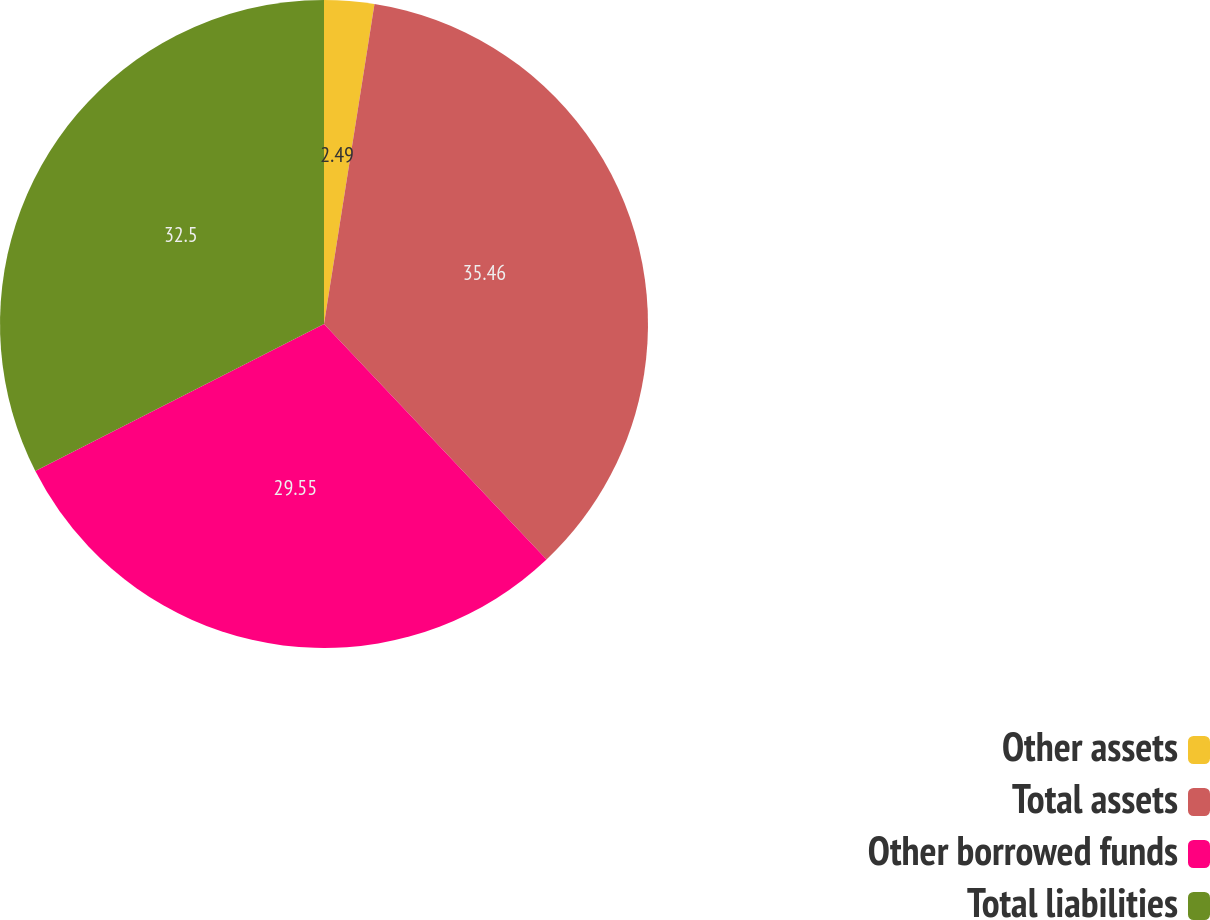<chart> <loc_0><loc_0><loc_500><loc_500><pie_chart><fcel>Other assets<fcel>Total assets<fcel>Other borrowed funds<fcel>Total liabilities<nl><fcel>2.49%<fcel>35.46%<fcel>29.55%<fcel>32.5%<nl></chart> 